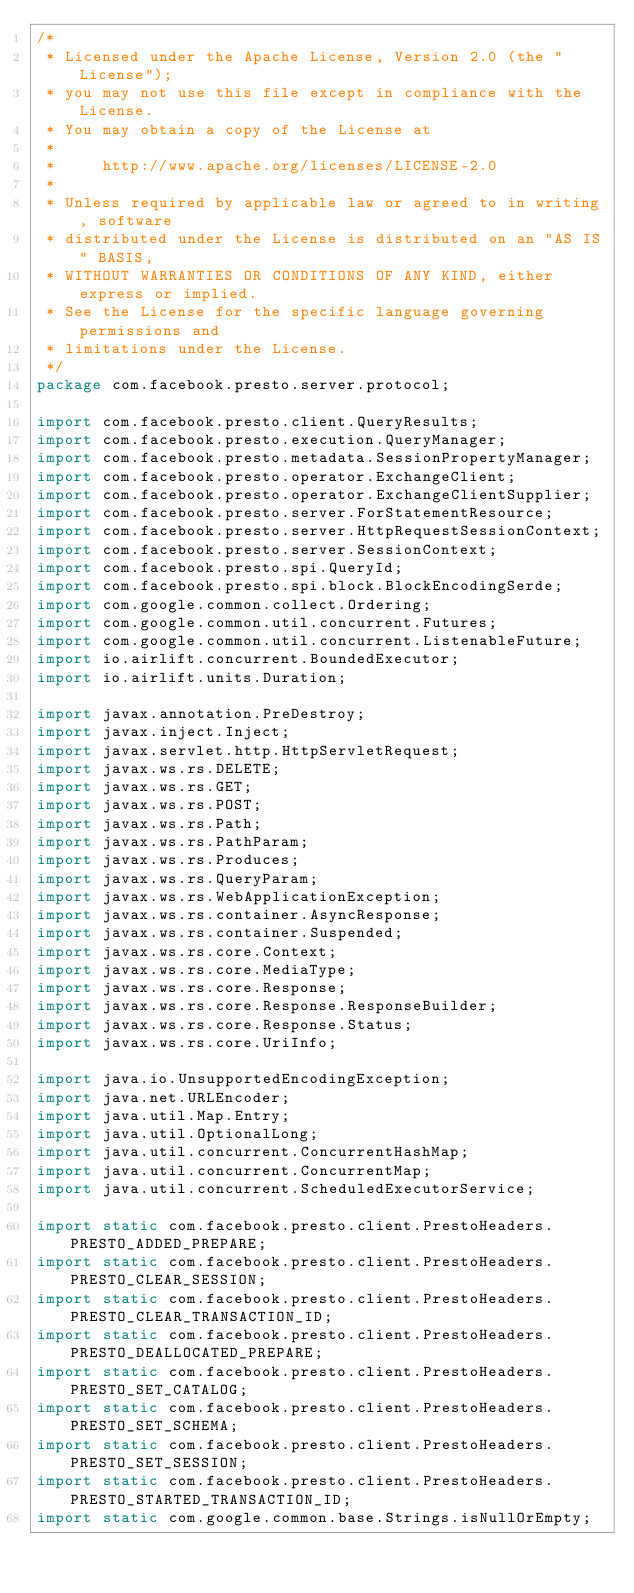<code> <loc_0><loc_0><loc_500><loc_500><_Java_>/*
 * Licensed under the Apache License, Version 2.0 (the "License");
 * you may not use this file except in compliance with the License.
 * You may obtain a copy of the License at
 *
 *     http://www.apache.org/licenses/LICENSE-2.0
 *
 * Unless required by applicable law or agreed to in writing, software
 * distributed under the License is distributed on an "AS IS" BASIS,
 * WITHOUT WARRANTIES OR CONDITIONS OF ANY KIND, either express or implied.
 * See the License for the specific language governing permissions and
 * limitations under the License.
 */
package com.facebook.presto.server.protocol;

import com.facebook.presto.client.QueryResults;
import com.facebook.presto.execution.QueryManager;
import com.facebook.presto.metadata.SessionPropertyManager;
import com.facebook.presto.operator.ExchangeClient;
import com.facebook.presto.operator.ExchangeClientSupplier;
import com.facebook.presto.server.ForStatementResource;
import com.facebook.presto.server.HttpRequestSessionContext;
import com.facebook.presto.server.SessionContext;
import com.facebook.presto.spi.QueryId;
import com.facebook.presto.spi.block.BlockEncodingSerde;
import com.google.common.collect.Ordering;
import com.google.common.util.concurrent.Futures;
import com.google.common.util.concurrent.ListenableFuture;
import io.airlift.concurrent.BoundedExecutor;
import io.airlift.units.Duration;

import javax.annotation.PreDestroy;
import javax.inject.Inject;
import javax.servlet.http.HttpServletRequest;
import javax.ws.rs.DELETE;
import javax.ws.rs.GET;
import javax.ws.rs.POST;
import javax.ws.rs.Path;
import javax.ws.rs.PathParam;
import javax.ws.rs.Produces;
import javax.ws.rs.QueryParam;
import javax.ws.rs.WebApplicationException;
import javax.ws.rs.container.AsyncResponse;
import javax.ws.rs.container.Suspended;
import javax.ws.rs.core.Context;
import javax.ws.rs.core.MediaType;
import javax.ws.rs.core.Response;
import javax.ws.rs.core.Response.ResponseBuilder;
import javax.ws.rs.core.Response.Status;
import javax.ws.rs.core.UriInfo;

import java.io.UnsupportedEncodingException;
import java.net.URLEncoder;
import java.util.Map.Entry;
import java.util.OptionalLong;
import java.util.concurrent.ConcurrentHashMap;
import java.util.concurrent.ConcurrentMap;
import java.util.concurrent.ScheduledExecutorService;

import static com.facebook.presto.client.PrestoHeaders.PRESTO_ADDED_PREPARE;
import static com.facebook.presto.client.PrestoHeaders.PRESTO_CLEAR_SESSION;
import static com.facebook.presto.client.PrestoHeaders.PRESTO_CLEAR_TRANSACTION_ID;
import static com.facebook.presto.client.PrestoHeaders.PRESTO_DEALLOCATED_PREPARE;
import static com.facebook.presto.client.PrestoHeaders.PRESTO_SET_CATALOG;
import static com.facebook.presto.client.PrestoHeaders.PRESTO_SET_SCHEMA;
import static com.facebook.presto.client.PrestoHeaders.PRESTO_SET_SESSION;
import static com.facebook.presto.client.PrestoHeaders.PRESTO_STARTED_TRANSACTION_ID;
import static com.google.common.base.Strings.isNullOrEmpty;</code> 